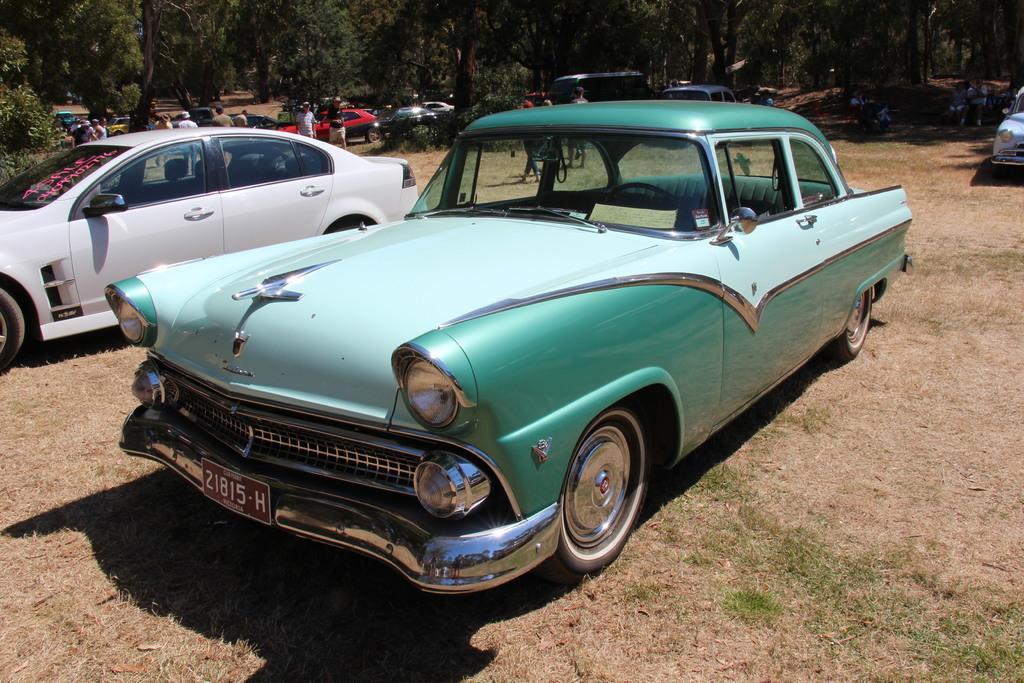Could you give a brief overview of what you see in this image? This picture is clicked outside. In the center we can see the group of vehicles seems to be parked on the ground and we can see the group of persons. In the background we can see the trees. 